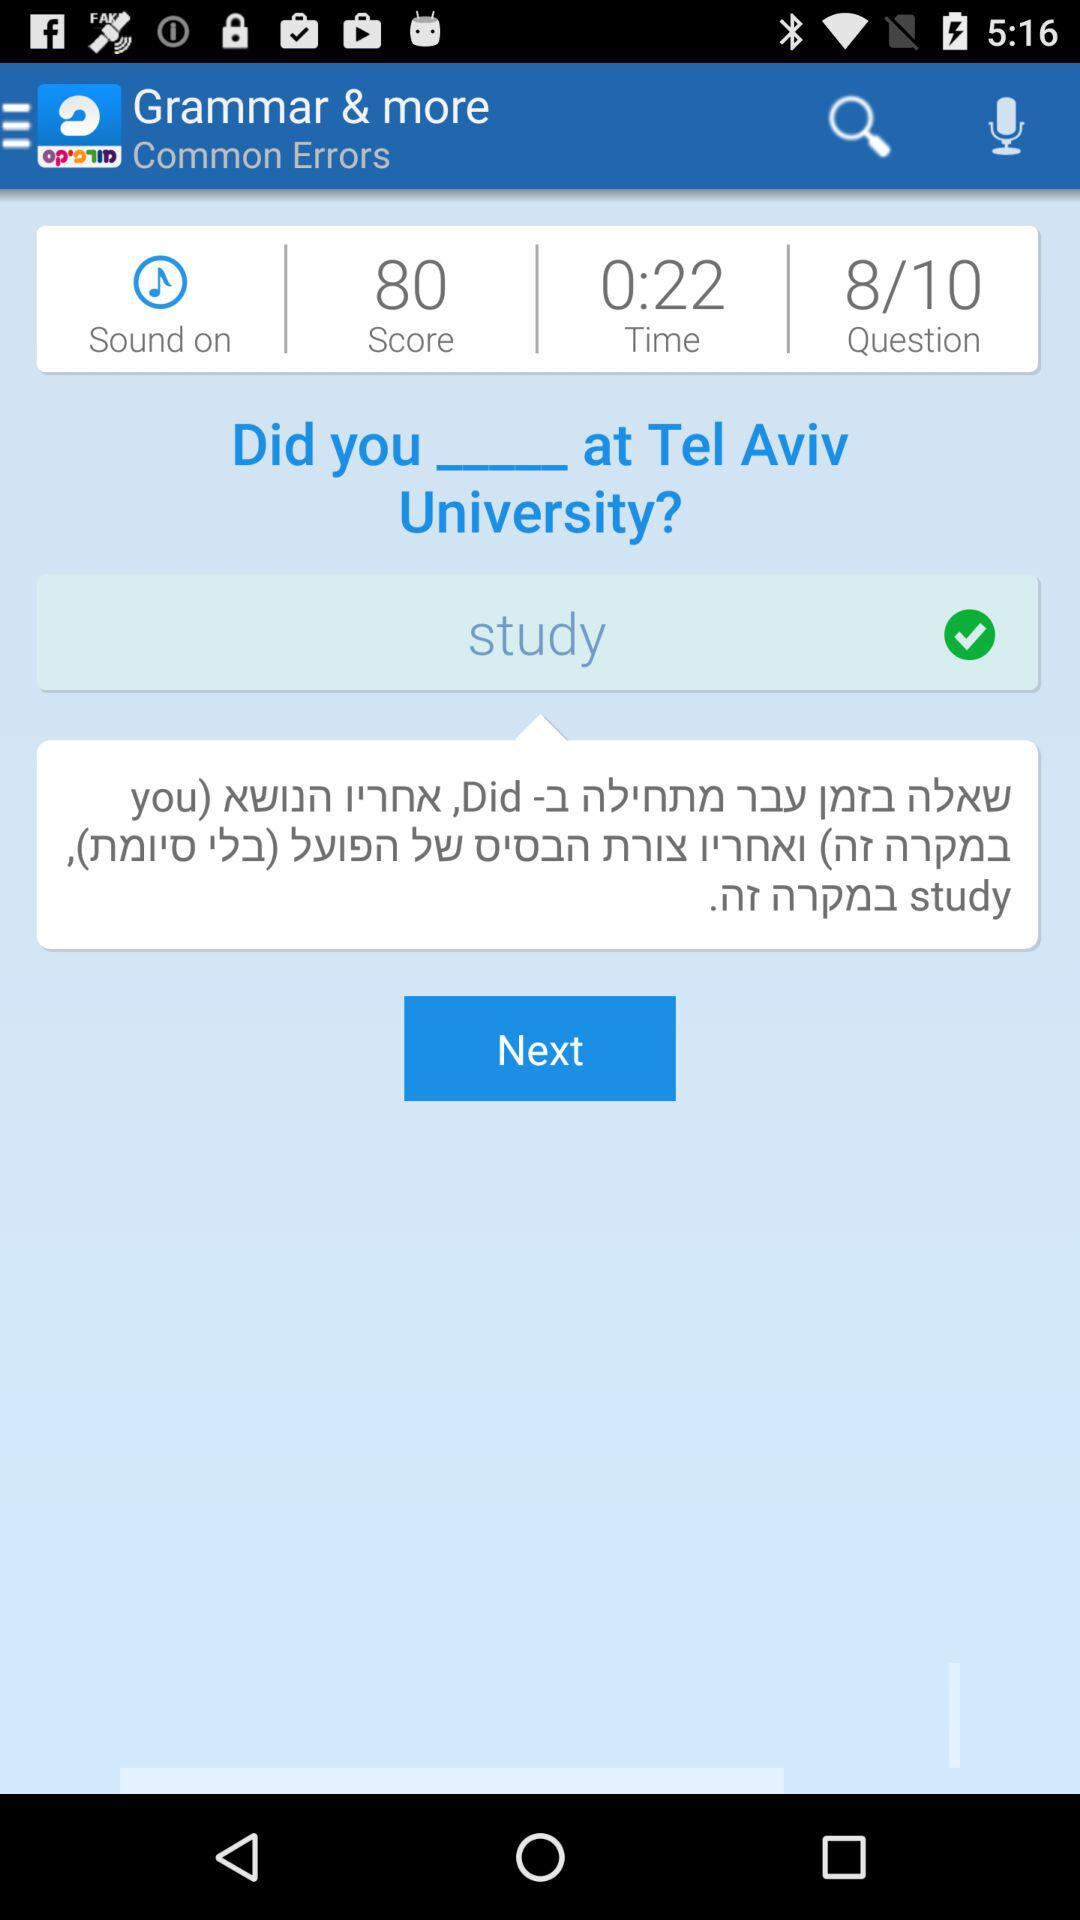What is the time? The time is 22 seconds. 